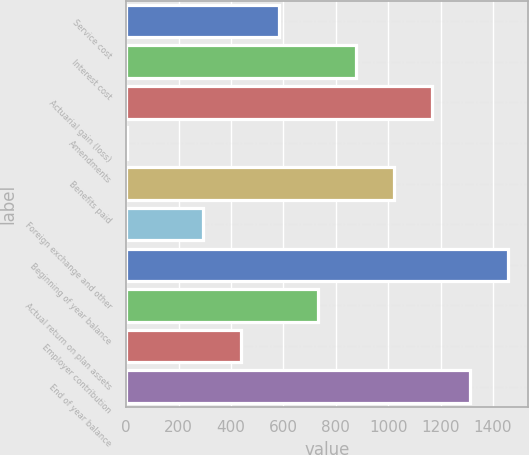<chart> <loc_0><loc_0><loc_500><loc_500><bar_chart><fcel>Service cost<fcel>Interest cost<fcel>Actuarial gain (loss)<fcel>Amendments<fcel>Benefits paid<fcel>Foreign exchange and other<fcel>Beginning of year balance<fcel>Actual return on plan assets<fcel>Employer contribution<fcel>End of year balance<nl><fcel>584.8<fcel>876.2<fcel>1167.6<fcel>2<fcel>1021.9<fcel>293.4<fcel>1459<fcel>730.5<fcel>439.1<fcel>1313.3<nl></chart> 